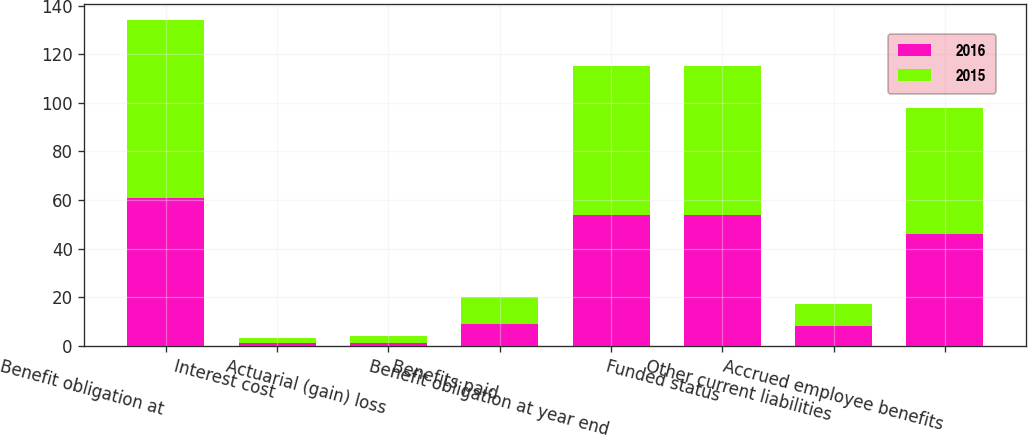<chart> <loc_0><loc_0><loc_500><loc_500><stacked_bar_chart><ecel><fcel>Benefit obligation at<fcel>Interest cost<fcel>Actuarial (gain) loss<fcel>Benefits paid<fcel>Benefit obligation at year end<fcel>Funded status<fcel>Other current liabilities<fcel>Accrued employee benefits<nl><fcel>2016<fcel>61<fcel>1<fcel>1<fcel>9<fcel>54<fcel>54<fcel>8<fcel>46<nl><fcel>2015<fcel>73<fcel>2<fcel>3<fcel>11<fcel>61<fcel>61<fcel>9<fcel>52<nl></chart> 